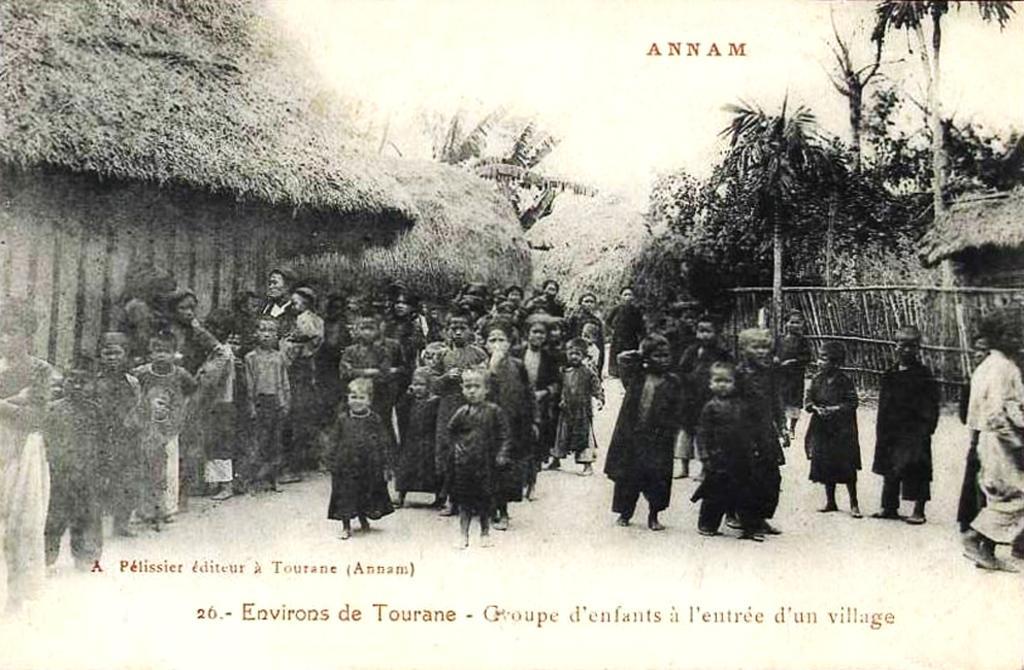Please provide a concise description of this image. There are people and we can see huts and trees. We can see some text. 